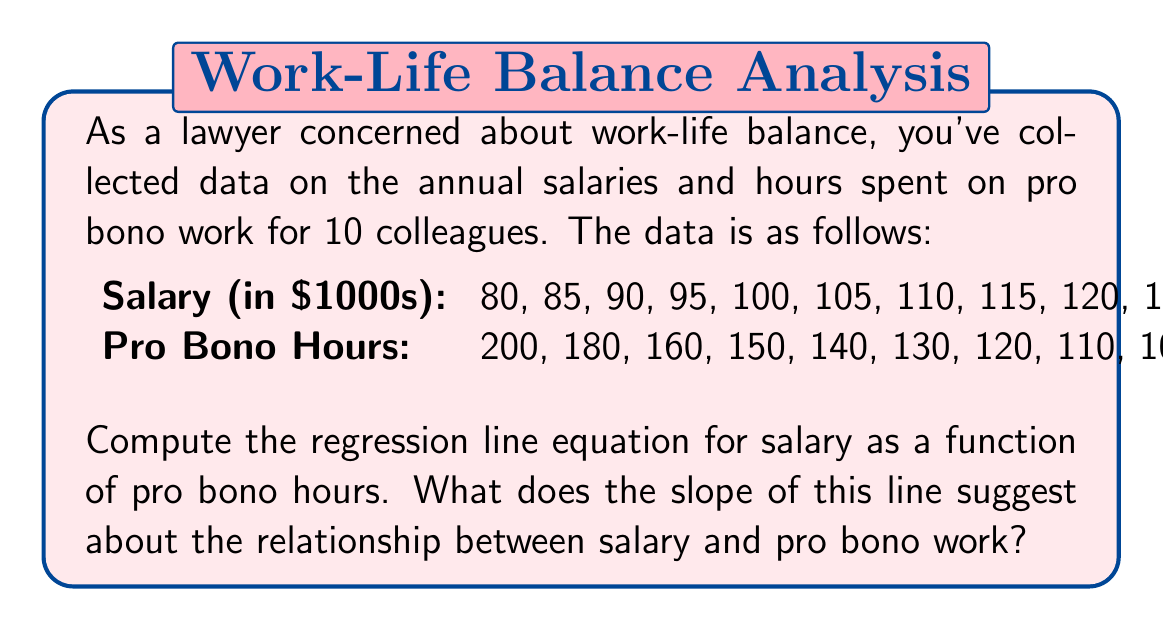Give your solution to this math problem. Let's approach this step-by-step:

1) First, we need to calculate some key values:
   $n = 10$ (number of data points)
   $\sum x = 1380$ (sum of pro bono hours)
   $\sum y = 1025$ (sum of salaries in $1000s)
   $\sum x^2 = 200,600$
   $\sum y^2 = 107,125$
   $\sum xy = 138,700$

2) Calculate the means:
   $\bar{x} = \frac{\sum x}{n} = 1380 / 10 = 138$
   $\bar{y} = \frac{\sum y}{n} = 1025 / 10 = 102.5$

3) Use the least squares formula to calculate the slope (b):
   $$b = \frac{n\sum xy - \sum x \sum y}{n\sum x^2 - (\sum x)^2}$$
   $$b = \frac{10(138,700) - 1380(1025)}{10(200,600) - 1380^2} = -0.4091$$

4) Calculate the y-intercept (a):
   $$a = \bar{y} - b\bar{x}$$
   $$a = 102.5 - (-0.4091)(138) = 159.4558$$

5) The regression line equation is:
   $$y = 159.4558 - 0.4091x$$

   Where y is the salary in $1000s and x is the number of pro bono hours.

6) Interpretation of the slope:
   The negative slope (-0.4091) suggests an inverse relationship between salary and pro bono hours. For each additional hour of pro bono work, the model predicts a decrease in salary of approximately $409.10.
Answer: $y = 159.4558 - 0.4091x$; negative slope indicates inverse relationship between salary and pro bono hours. 